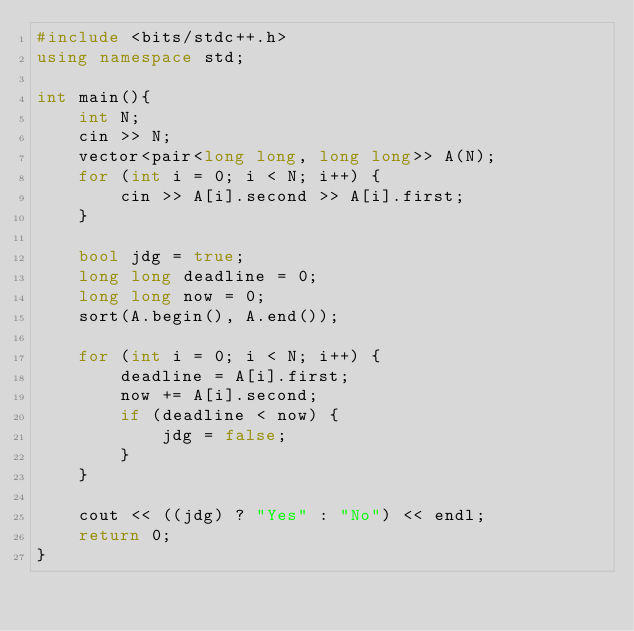Convert code to text. <code><loc_0><loc_0><loc_500><loc_500><_C++_>#include <bits/stdc++.h>
using namespace std;

int main(){
    int N;
    cin >> N;
    vector<pair<long long, long long>> A(N);
    for (int i = 0; i < N; i++) {
        cin >> A[i].second >> A[i].first;
    }
    
    bool jdg = true;
    long long deadline = 0;
    long long now = 0;
    sort(A.begin(), A.end());
    
    for (int i = 0; i < N; i++) {
        deadline = A[i].first;
        now += A[i].second;
        if (deadline < now) {
            jdg = false;
        }
    }
    
    cout << ((jdg) ? "Yes" : "No") << endl;
    return 0;
}</code> 